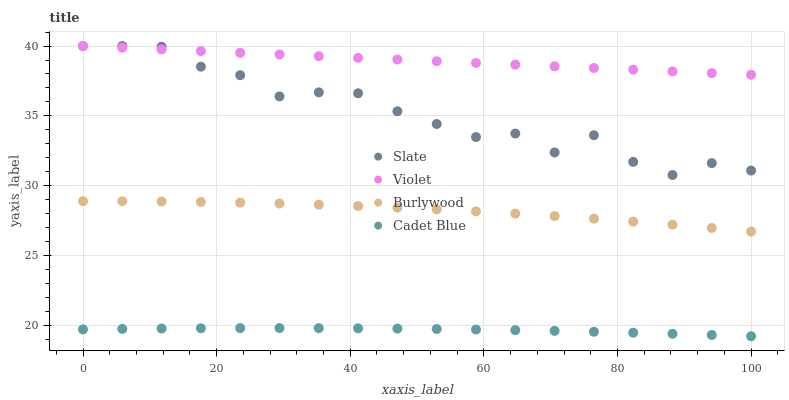Does Cadet Blue have the minimum area under the curve?
Answer yes or no. Yes. Does Violet have the maximum area under the curve?
Answer yes or no. Yes. Does Slate have the minimum area under the curve?
Answer yes or no. No. Does Slate have the maximum area under the curve?
Answer yes or no. No. Is Violet the smoothest?
Answer yes or no. Yes. Is Slate the roughest?
Answer yes or no. Yes. Is Cadet Blue the smoothest?
Answer yes or no. No. Is Cadet Blue the roughest?
Answer yes or no. No. Does Cadet Blue have the lowest value?
Answer yes or no. Yes. Does Slate have the lowest value?
Answer yes or no. No. Does Violet have the highest value?
Answer yes or no. Yes. Does Cadet Blue have the highest value?
Answer yes or no. No. Is Burlywood less than Violet?
Answer yes or no. Yes. Is Burlywood greater than Cadet Blue?
Answer yes or no. Yes. Does Slate intersect Violet?
Answer yes or no. Yes. Is Slate less than Violet?
Answer yes or no. No. Is Slate greater than Violet?
Answer yes or no. No. Does Burlywood intersect Violet?
Answer yes or no. No. 